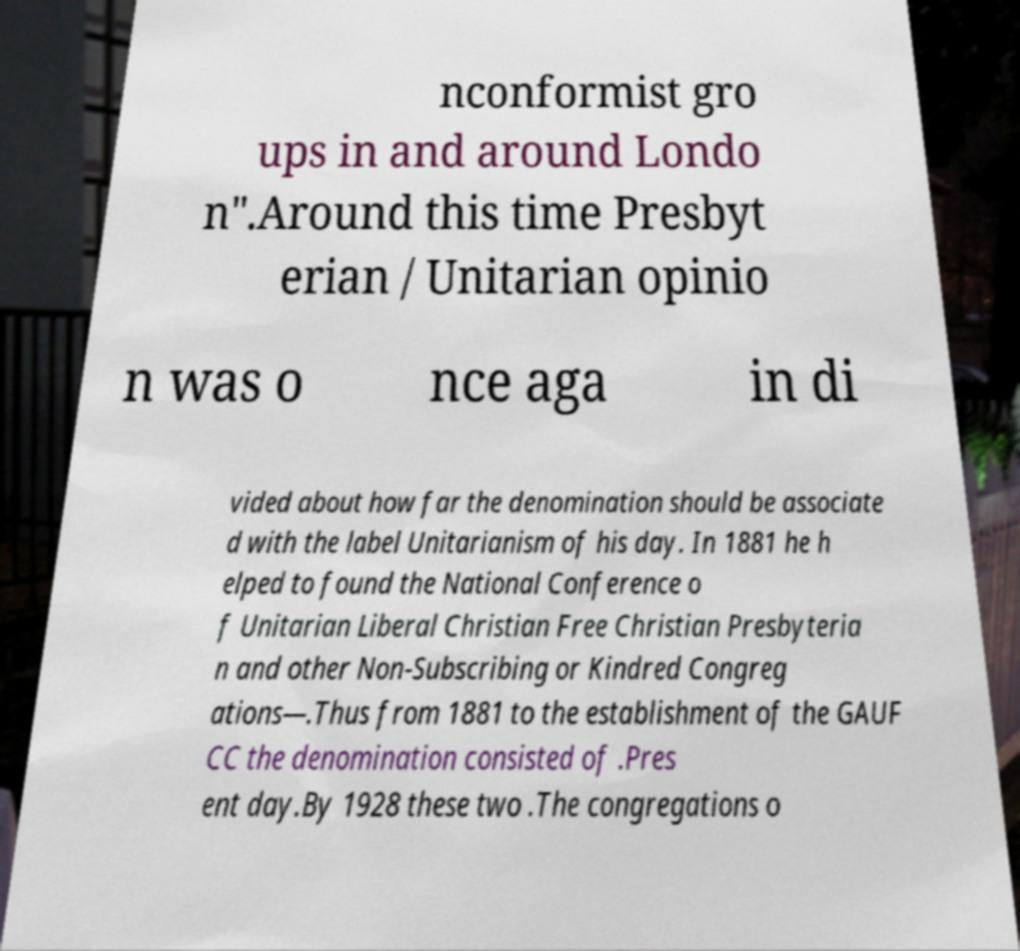What messages or text are displayed in this image? I need them in a readable, typed format. nconformist gro ups in and around Londo n".Around this time Presbyt erian / Unitarian opinio n was o nce aga in di vided about how far the denomination should be associate d with the label Unitarianism of his day. In 1881 he h elped to found the National Conference o f Unitarian Liberal Christian Free Christian Presbyteria n and other Non-Subscribing or Kindred Congreg ations—.Thus from 1881 to the establishment of the GAUF CC the denomination consisted of .Pres ent day.By 1928 these two .The congregations o 